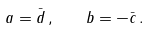<formula> <loc_0><loc_0><loc_500><loc_500>a = \bar { d } \, , \quad b = - \bar { c } \, .</formula> 